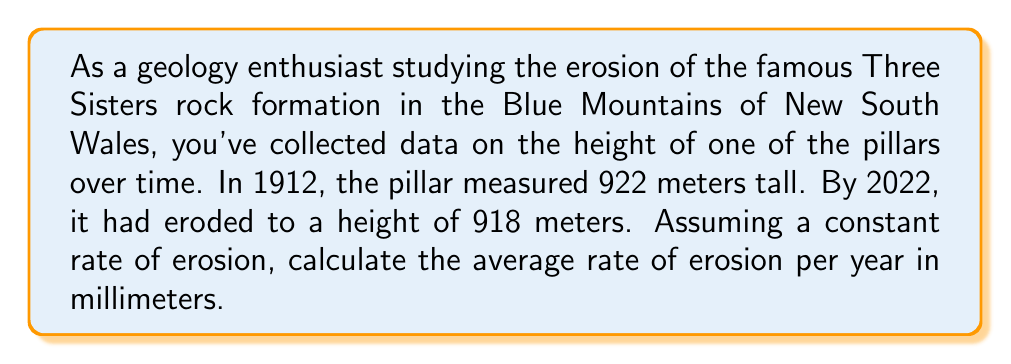Can you answer this question? Let's approach this step-by-step:

1) First, we need to calculate the total change in height:
   $$ \text{Total erosion} = 922\text{ m} - 918\text{ m} = 4\text{ m} $$

2) Next, we need to determine the time period:
   $$ \text{Time period} = 2022 - 1912 = 110\text{ years} $$

3) Now, we can calculate the rate of erosion per year:
   $$ \text{Rate of erosion per year} = \frac{\text{Total erosion}}{\text{Time period}} = \frac{4\text{ m}}{110\text{ years}} $$

4) Simplify this fraction:
   $$ \frac{4\text{ m}}{110\text{ years}} = \frac{1\text{ m}}{27.5\text{ years}} $$

5) To convert this to millimeters per year, we multiply by 1000 (as there are 1000 mm in 1 m):
   $$ \frac{1000\text{ mm}}{27.5\text{ years}} \approx 36.36\text{ mm/year} $$

6) Rounding to two decimal places:
   $$ 36.36\text{ mm/year} \approx 36.36\text{ mm/year} $$
Answer: 36.36 mm/year 